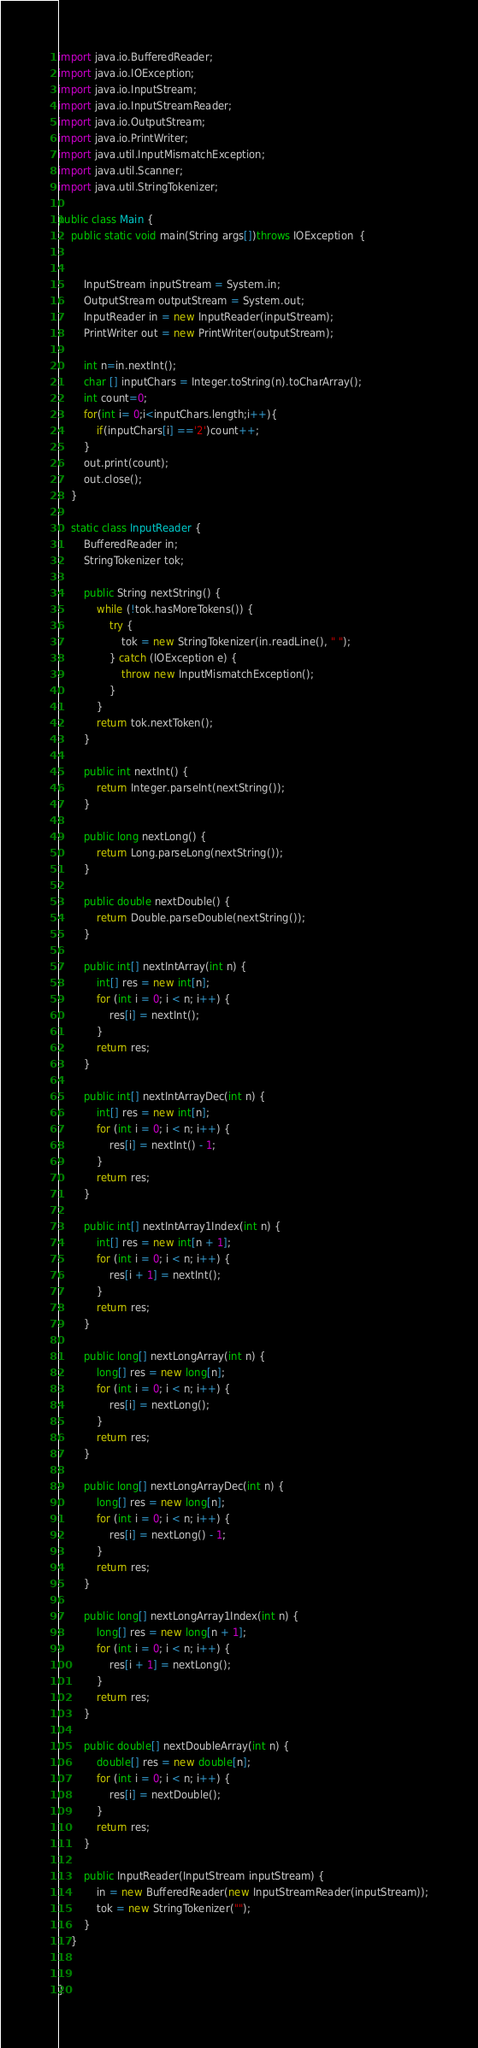<code> <loc_0><loc_0><loc_500><loc_500><_Java_>import java.io.BufferedReader;
import java.io.IOException;
import java.io.InputStream;
import java.io.InputStreamReader;
import java.io.OutputStream;
import java.io.PrintWriter;
import java.util.InputMismatchException;
import java.util.Scanner;
import java.util.StringTokenizer;
 
public class Main {
	public static void main(String args[])throws IOException  {
 
	
		InputStream inputStream = System.in;
		OutputStream outputStream = System.out;
		InputReader in = new InputReader(inputStream);
		PrintWriter out = new PrintWriter(outputStream);
		
		int n=in.nextInt();
		char [] inputChars = Integer.toString(n).toCharArray();
		int count=0;
		for(int i= 0;i<inputChars.length;i++){
			if(inputChars[i] =='2')count++;
		}
		out.print(count);
		out.close();
	}
	
	static class InputReader {
		BufferedReader in;
		StringTokenizer tok;
 
		public String nextString() {
			while (!tok.hasMoreTokens()) {
				try {
					tok = new StringTokenizer(in.readLine(), " ");
				} catch (IOException e) {
					throw new InputMismatchException();
				}
			}
			return tok.nextToken();
		}
 
		public int nextInt() {
			return Integer.parseInt(nextString());
		}
 
		public long nextLong() {
			return Long.parseLong(nextString());
		}
 
		public double nextDouble() {
			return Double.parseDouble(nextString());
		}
 
		public int[] nextIntArray(int n) {
			int[] res = new int[n];
			for (int i = 0; i < n; i++) {
				res[i] = nextInt();
			}
			return res;
		}
 
		public int[] nextIntArrayDec(int n) {
			int[] res = new int[n];
			for (int i = 0; i < n; i++) {
				res[i] = nextInt() - 1;
			}
			return res;
		}
 
		public int[] nextIntArray1Index(int n) {
			int[] res = new int[n + 1];
			for (int i = 0; i < n; i++) {
				res[i + 1] = nextInt();
			}
			return res;
		}
 
		public long[] nextLongArray(int n) {
			long[] res = new long[n];
			for (int i = 0; i < n; i++) {
				res[i] = nextLong();
			}
			return res;
		}
 
		public long[] nextLongArrayDec(int n) {
			long[] res = new long[n];
			for (int i = 0; i < n; i++) {
				res[i] = nextLong() - 1;
			}
			return res;
		}
 
		public long[] nextLongArray1Index(int n) {
			long[] res = new long[n + 1];
			for (int i = 0; i < n; i++) {
				res[i + 1] = nextLong();
			}
			return res;
		}
 
		public double[] nextDoubleArray(int n) {
			double[] res = new double[n];
			for (int i = 0; i < n; i++) {
				res[i] = nextDouble();
			}
			return res;
		}
 
		public InputReader(InputStream inputStream) {
			in = new BufferedReader(new InputStreamReader(inputStream));
			tok = new StringTokenizer("");
		}
	}
 
	
}
</code> 